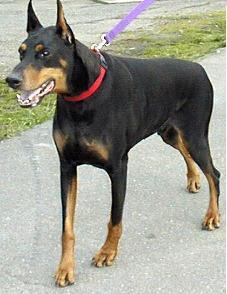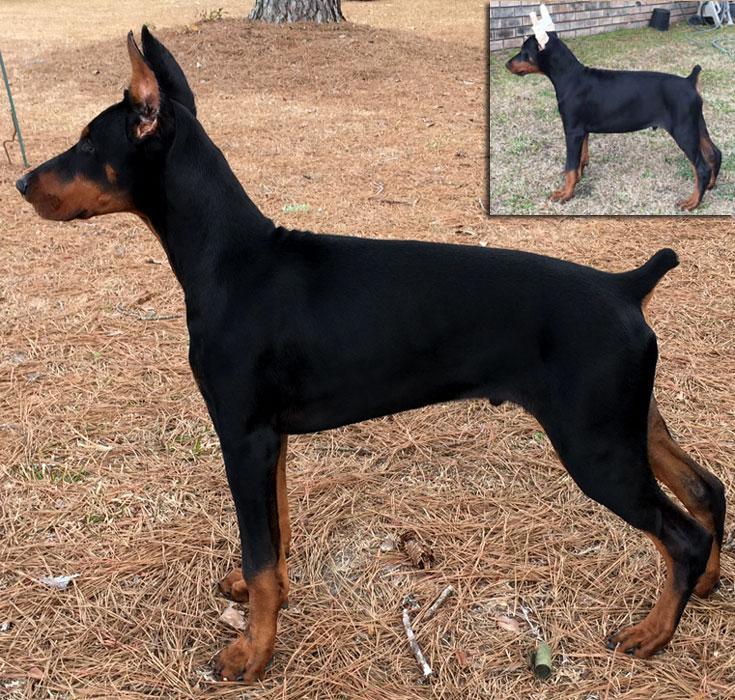The first image is the image on the left, the second image is the image on the right. For the images shown, is this caption "Each image features a doberman with erect, upright ears, one of the dobermans depicted has an open mouth, and no doberman has a long tail." true? Answer yes or no. Yes. 